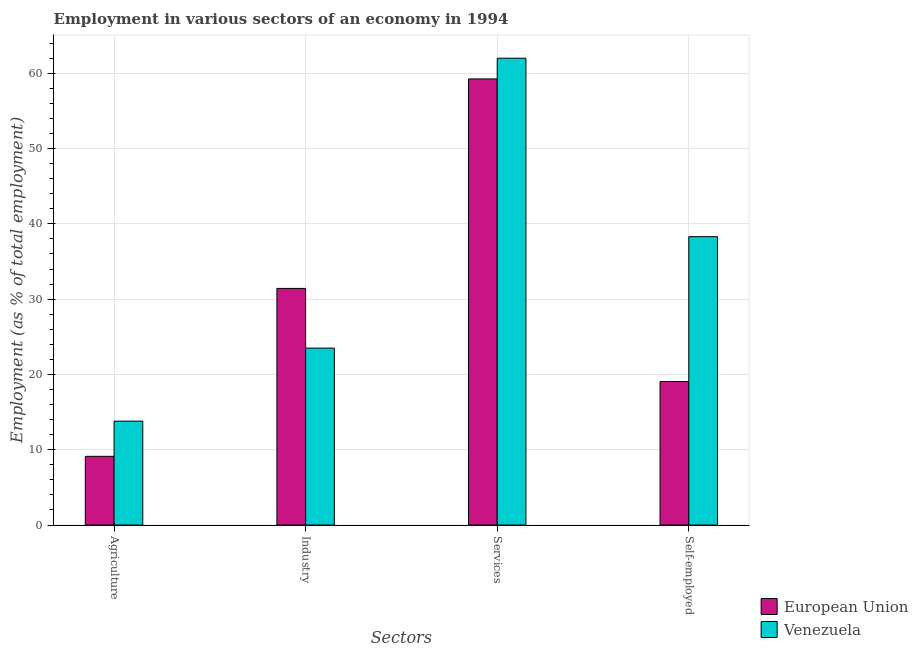How many different coloured bars are there?
Offer a terse response. 2. Are the number of bars on each tick of the X-axis equal?
Offer a terse response. Yes. How many bars are there on the 3rd tick from the left?
Make the answer very short. 2. What is the label of the 4th group of bars from the left?
Your response must be concise. Self-employed. What is the percentage of workers in agriculture in Venezuela?
Make the answer very short. 13.8. Across all countries, what is the maximum percentage of workers in agriculture?
Give a very brief answer. 13.8. Across all countries, what is the minimum percentage of workers in agriculture?
Your answer should be compact. 9.13. In which country was the percentage of workers in industry maximum?
Provide a short and direct response. European Union. In which country was the percentage of workers in services minimum?
Offer a terse response. European Union. What is the total percentage of workers in services in the graph?
Keep it short and to the point. 121.25. What is the difference between the percentage of workers in industry in European Union and that in Venezuela?
Your response must be concise. 7.93. What is the difference between the percentage of self employed workers in European Union and the percentage of workers in agriculture in Venezuela?
Your answer should be compact. 5.26. What is the average percentage of self employed workers per country?
Give a very brief answer. 28.68. What is the difference between the percentage of workers in services and percentage of self employed workers in Venezuela?
Offer a very short reply. 23.7. What is the ratio of the percentage of self employed workers in European Union to that in Venezuela?
Your answer should be very brief. 0.5. Is the percentage of workers in agriculture in Venezuela less than that in European Union?
Keep it short and to the point. No. What is the difference between the highest and the second highest percentage of self employed workers?
Keep it short and to the point. 19.24. What is the difference between the highest and the lowest percentage of workers in services?
Ensure brevity in your answer.  2.75. In how many countries, is the percentage of self employed workers greater than the average percentage of self employed workers taken over all countries?
Your response must be concise. 1. What does the 2nd bar from the left in Industry represents?
Give a very brief answer. Venezuela. What does the 1st bar from the right in Agriculture represents?
Make the answer very short. Venezuela. How many bars are there?
Ensure brevity in your answer.  8. Are the values on the major ticks of Y-axis written in scientific E-notation?
Provide a short and direct response. No. Does the graph contain any zero values?
Provide a short and direct response. No. Where does the legend appear in the graph?
Keep it short and to the point. Bottom right. How many legend labels are there?
Provide a succinct answer. 2. What is the title of the graph?
Ensure brevity in your answer.  Employment in various sectors of an economy in 1994. Does "Panama" appear as one of the legend labels in the graph?
Your answer should be compact. No. What is the label or title of the X-axis?
Give a very brief answer. Sectors. What is the label or title of the Y-axis?
Ensure brevity in your answer.  Employment (as % of total employment). What is the Employment (as % of total employment) of European Union in Agriculture?
Offer a terse response. 9.13. What is the Employment (as % of total employment) of Venezuela in Agriculture?
Your response must be concise. 13.8. What is the Employment (as % of total employment) in European Union in Industry?
Keep it short and to the point. 31.43. What is the Employment (as % of total employment) in European Union in Services?
Ensure brevity in your answer.  59.25. What is the Employment (as % of total employment) of Venezuela in Services?
Provide a succinct answer. 62. What is the Employment (as % of total employment) of European Union in Self-employed?
Make the answer very short. 19.06. What is the Employment (as % of total employment) of Venezuela in Self-employed?
Provide a short and direct response. 38.3. Across all Sectors, what is the maximum Employment (as % of total employment) of European Union?
Provide a short and direct response. 59.25. Across all Sectors, what is the maximum Employment (as % of total employment) in Venezuela?
Your answer should be compact. 62. Across all Sectors, what is the minimum Employment (as % of total employment) in European Union?
Make the answer very short. 9.13. Across all Sectors, what is the minimum Employment (as % of total employment) in Venezuela?
Make the answer very short. 13.8. What is the total Employment (as % of total employment) in European Union in the graph?
Make the answer very short. 118.86. What is the total Employment (as % of total employment) in Venezuela in the graph?
Ensure brevity in your answer.  137.6. What is the difference between the Employment (as % of total employment) in European Union in Agriculture and that in Industry?
Your answer should be very brief. -22.3. What is the difference between the Employment (as % of total employment) of Venezuela in Agriculture and that in Industry?
Your answer should be very brief. -9.7. What is the difference between the Employment (as % of total employment) in European Union in Agriculture and that in Services?
Ensure brevity in your answer.  -50.12. What is the difference between the Employment (as % of total employment) in Venezuela in Agriculture and that in Services?
Your answer should be very brief. -48.2. What is the difference between the Employment (as % of total employment) of European Union in Agriculture and that in Self-employed?
Your response must be concise. -9.93. What is the difference between the Employment (as % of total employment) in Venezuela in Agriculture and that in Self-employed?
Offer a terse response. -24.5. What is the difference between the Employment (as % of total employment) in European Union in Industry and that in Services?
Make the answer very short. -27.82. What is the difference between the Employment (as % of total employment) in Venezuela in Industry and that in Services?
Your response must be concise. -38.5. What is the difference between the Employment (as % of total employment) in European Union in Industry and that in Self-employed?
Offer a terse response. 12.37. What is the difference between the Employment (as % of total employment) in Venezuela in Industry and that in Self-employed?
Offer a terse response. -14.8. What is the difference between the Employment (as % of total employment) in European Union in Services and that in Self-employed?
Offer a terse response. 40.19. What is the difference between the Employment (as % of total employment) of Venezuela in Services and that in Self-employed?
Your answer should be very brief. 23.7. What is the difference between the Employment (as % of total employment) of European Union in Agriculture and the Employment (as % of total employment) of Venezuela in Industry?
Offer a terse response. -14.37. What is the difference between the Employment (as % of total employment) in European Union in Agriculture and the Employment (as % of total employment) in Venezuela in Services?
Offer a very short reply. -52.87. What is the difference between the Employment (as % of total employment) in European Union in Agriculture and the Employment (as % of total employment) in Venezuela in Self-employed?
Ensure brevity in your answer.  -29.17. What is the difference between the Employment (as % of total employment) of European Union in Industry and the Employment (as % of total employment) of Venezuela in Services?
Ensure brevity in your answer.  -30.57. What is the difference between the Employment (as % of total employment) in European Union in Industry and the Employment (as % of total employment) in Venezuela in Self-employed?
Make the answer very short. -6.87. What is the difference between the Employment (as % of total employment) in European Union in Services and the Employment (as % of total employment) in Venezuela in Self-employed?
Provide a short and direct response. 20.95. What is the average Employment (as % of total employment) of European Union per Sectors?
Offer a very short reply. 29.72. What is the average Employment (as % of total employment) of Venezuela per Sectors?
Make the answer very short. 34.4. What is the difference between the Employment (as % of total employment) of European Union and Employment (as % of total employment) of Venezuela in Agriculture?
Your answer should be compact. -4.67. What is the difference between the Employment (as % of total employment) of European Union and Employment (as % of total employment) of Venezuela in Industry?
Offer a terse response. 7.93. What is the difference between the Employment (as % of total employment) in European Union and Employment (as % of total employment) in Venezuela in Services?
Make the answer very short. -2.75. What is the difference between the Employment (as % of total employment) in European Union and Employment (as % of total employment) in Venezuela in Self-employed?
Your response must be concise. -19.24. What is the ratio of the Employment (as % of total employment) of European Union in Agriculture to that in Industry?
Ensure brevity in your answer.  0.29. What is the ratio of the Employment (as % of total employment) in Venezuela in Agriculture to that in Industry?
Your answer should be compact. 0.59. What is the ratio of the Employment (as % of total employment) of European Union in Agriculture to that in Services?
Keep it short and to the point. 0.15. What is the ratio of the Employment (as % of total employment) of Venezuela in Agriculture to that in Services?
Provide a succinct answer. 0.22. What is the ratio of the Employment (as % of total employment) in European Union in Agriculture to that in Self-employed?
Keep it short and to the point. 0.48. What is the ratio of the Employment (as % of total employment) in Venezuela in Agriculture to that in Self-employed?
Offer a very short reply. 0.36. What is the ratio of the Employment (as % of total employment) of European Union in Industry to that in Services?
Offer a terse response. 0.53. What is the ratio of the Employment (as % of total employment) in Venezuela in Industry to that in Services?
Keep it short and to the point. 0.38. What is the ratio of the Employment (as % of total employment) in European Union in Industry to that in Self-employed?
Provide a short and direct response. 1.65. What is the ratio of the Employment (as % of total employment) of Venezuela in Industry to that in Self-employed?
Your response must be concise. 0.61. What is the ratio of the Employment (as % of total employment) in European Union in Services to that in Self-employed?
Offer a terse response. 3.11. What is the ratio of the Employment (as % of total employment) of Venezuela in Services to that in Self-employed?
Your answer should be compact. 1.62. What is the difference between the highest and the second highest Employment (as % of total employment) in European Union?
Make the answer very short. 27.82. What is the difference between the highest and the second highest Employment (as % of total employment) of Venezuela?
Make the answer very short. 23.7. What is the difference between the highest and the lowest Employment (as % of total employment) in European Union?
Offer a very short reply. 50.12. What is the difference between the highest and the lowest Employment (as % of total employment) in Venezuela?
Ensure brevity in your answer.  48.2. 